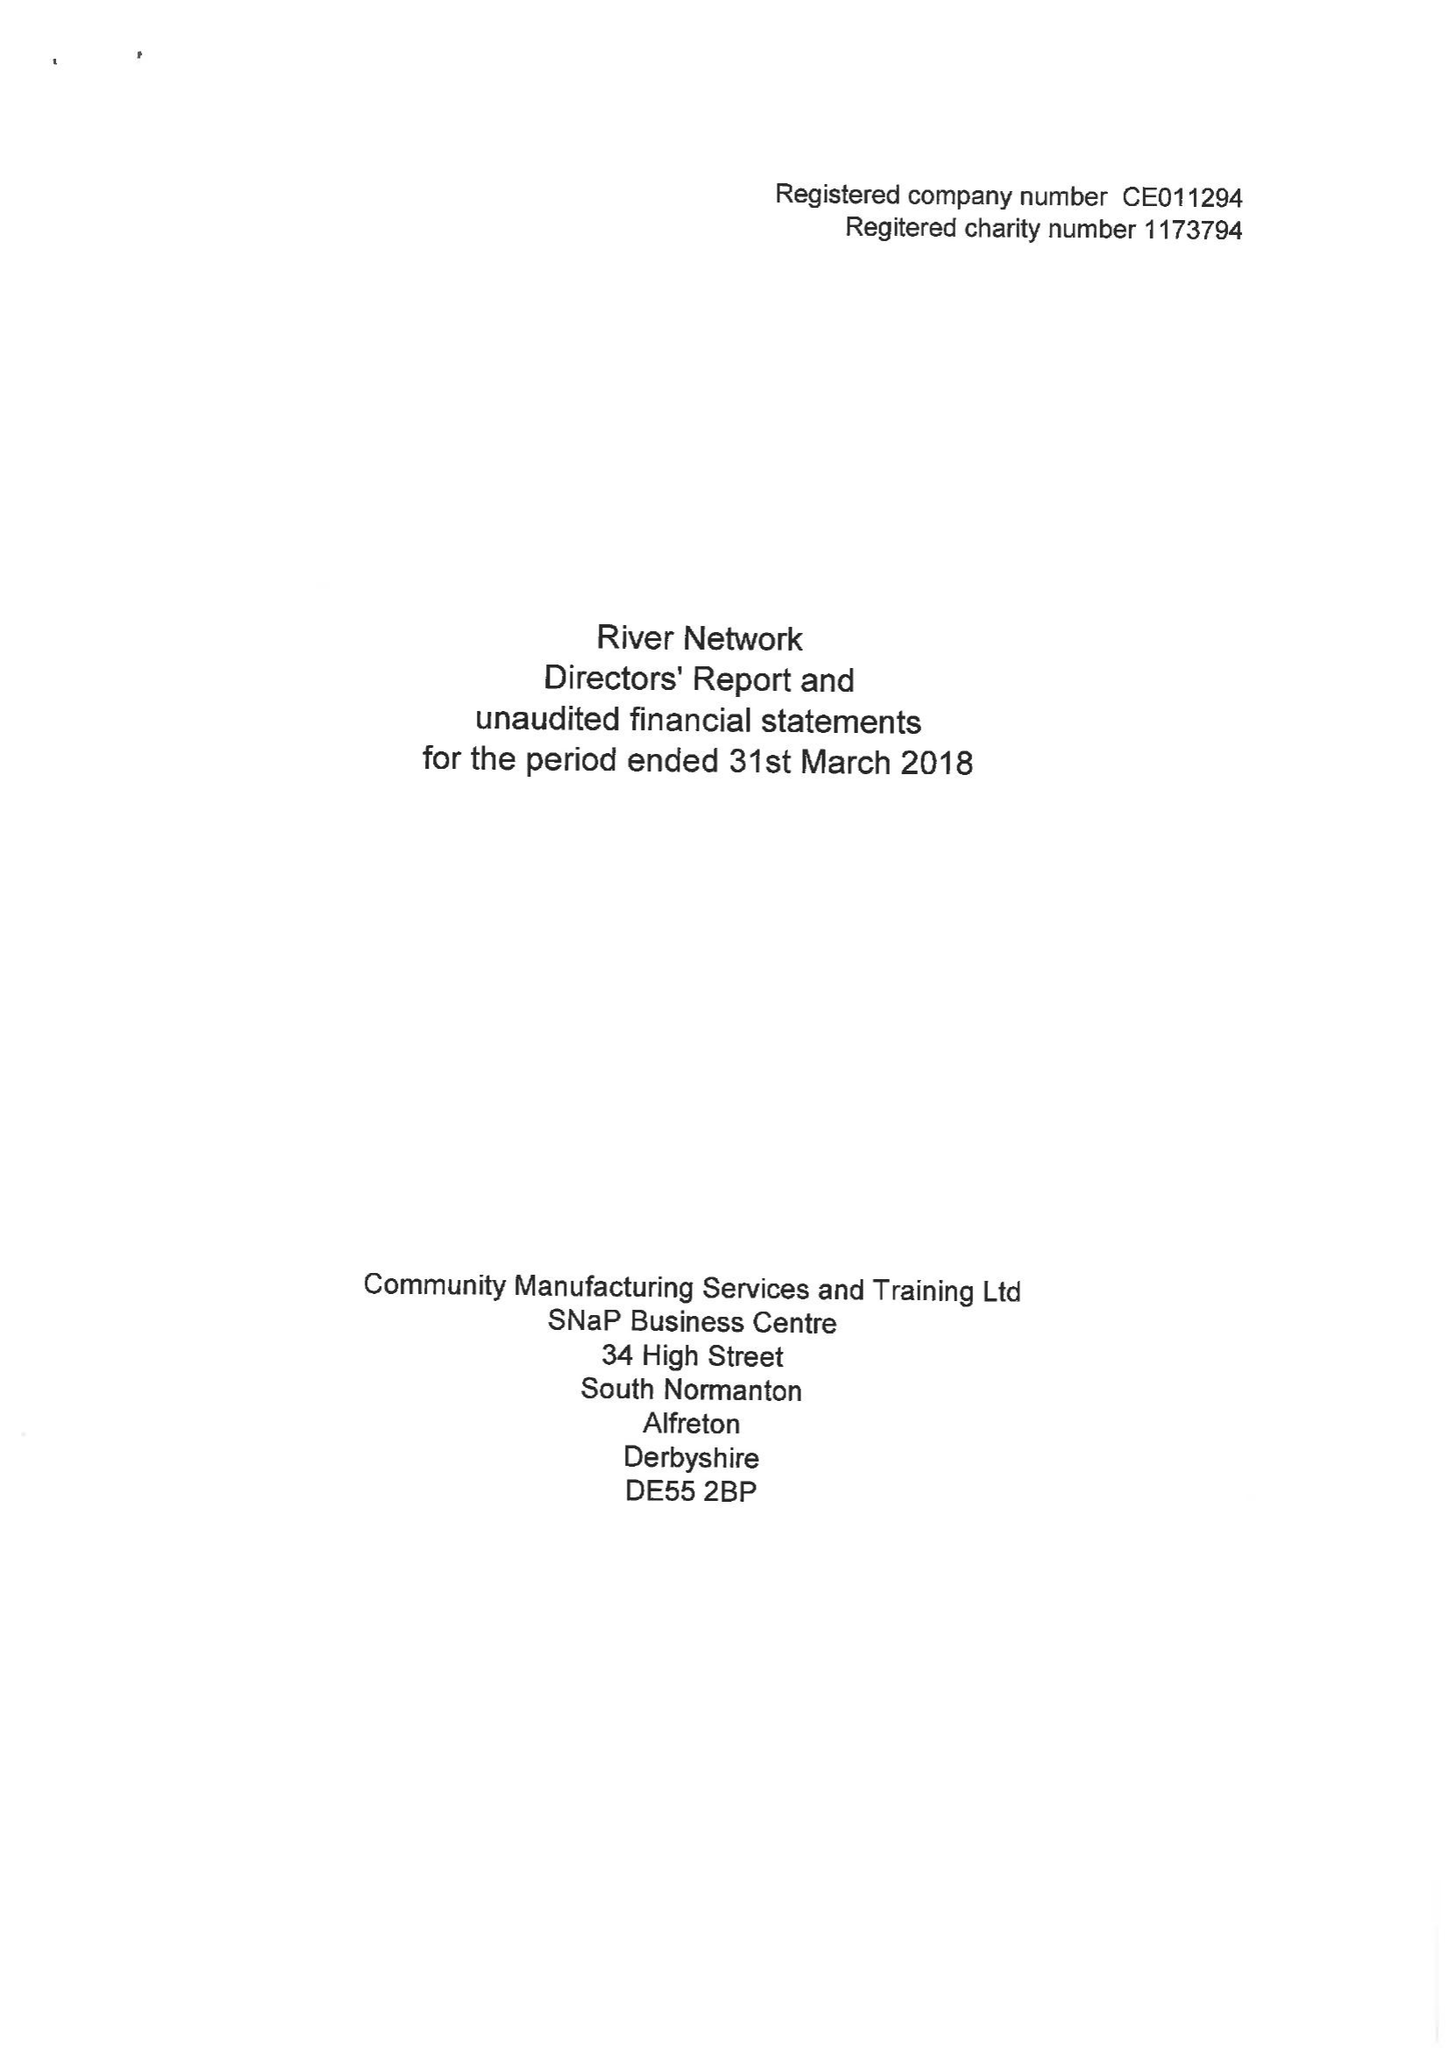What is the value for the report_date?
Answer the question using a single word or phrase. 2018-03-31 